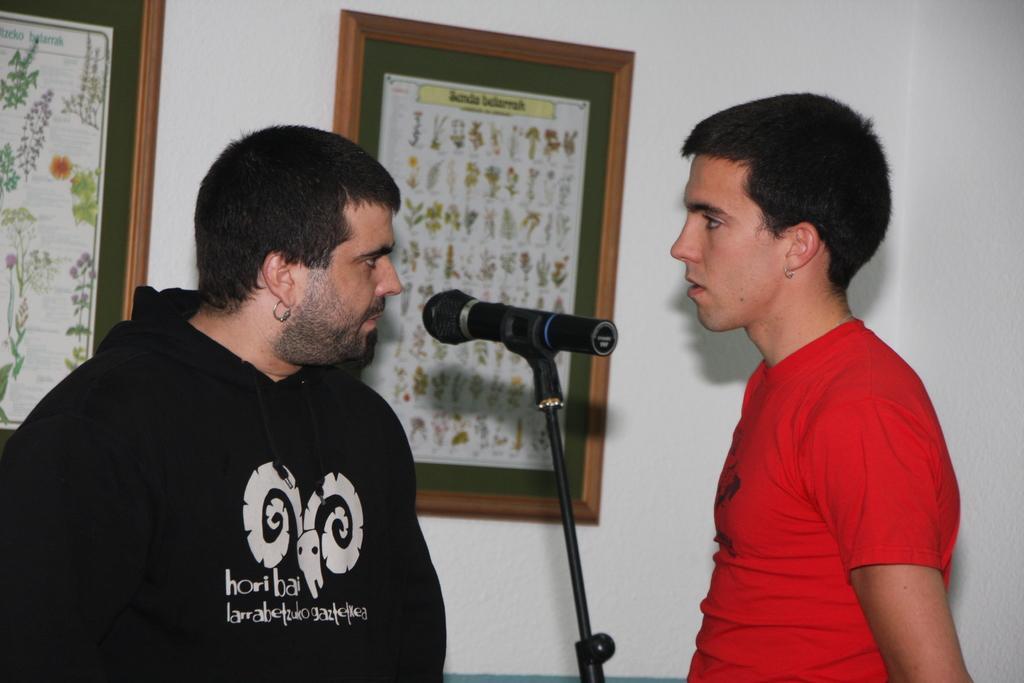How would you summarize this image in a sentence or two? In this image I can see a person wearing black color dress is standing and another person wearing red colored t shirt is standing. I can see a microphone in between them. In the background I can see the white colored wall and two boards attached to the wall. 